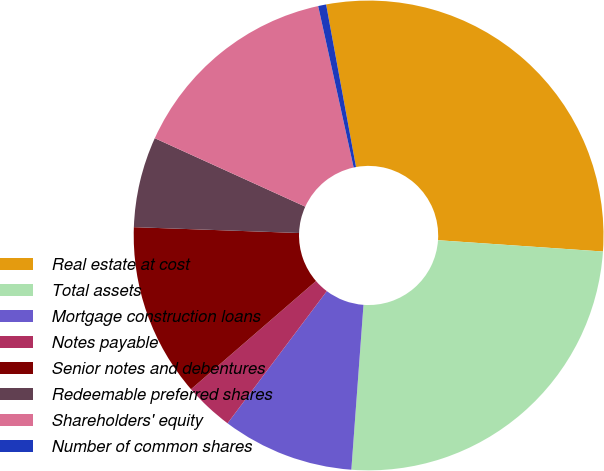Convert chart to OTSL. <chart><loc_0><loc_0><loc_500><loc_500><pie_chart><fcel>Real estate at cost<fcel>Total assets<fcel>Mortgage construction loans<fcel>Notes payable<fcel>Senior notes and debentures<fcel>Redeemable preferred shares<fcel>Shareholders' equity<fcel>Number of common shares<nl><fcel>28.98%<fcel>25.08%<fcel>9.08%<fcel>3.39%<fcel>11.92%<fcel>6.23%<fcel>14.76%<fcel>0.55%<nl></chart> 